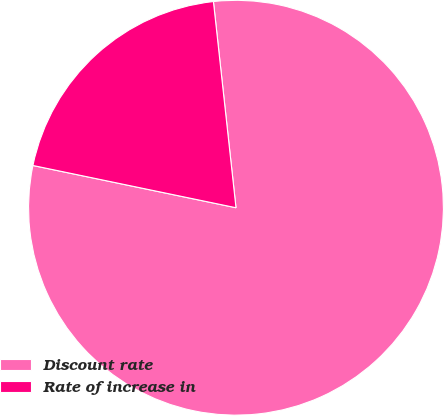<chart> <loc_0><loc_0><loc_500><loc_500><pie_chart><fcel>Discount rate<fcel>Rate of increase in<nl><fcel>80.0%<fcel>20.0%<nl></chart> 